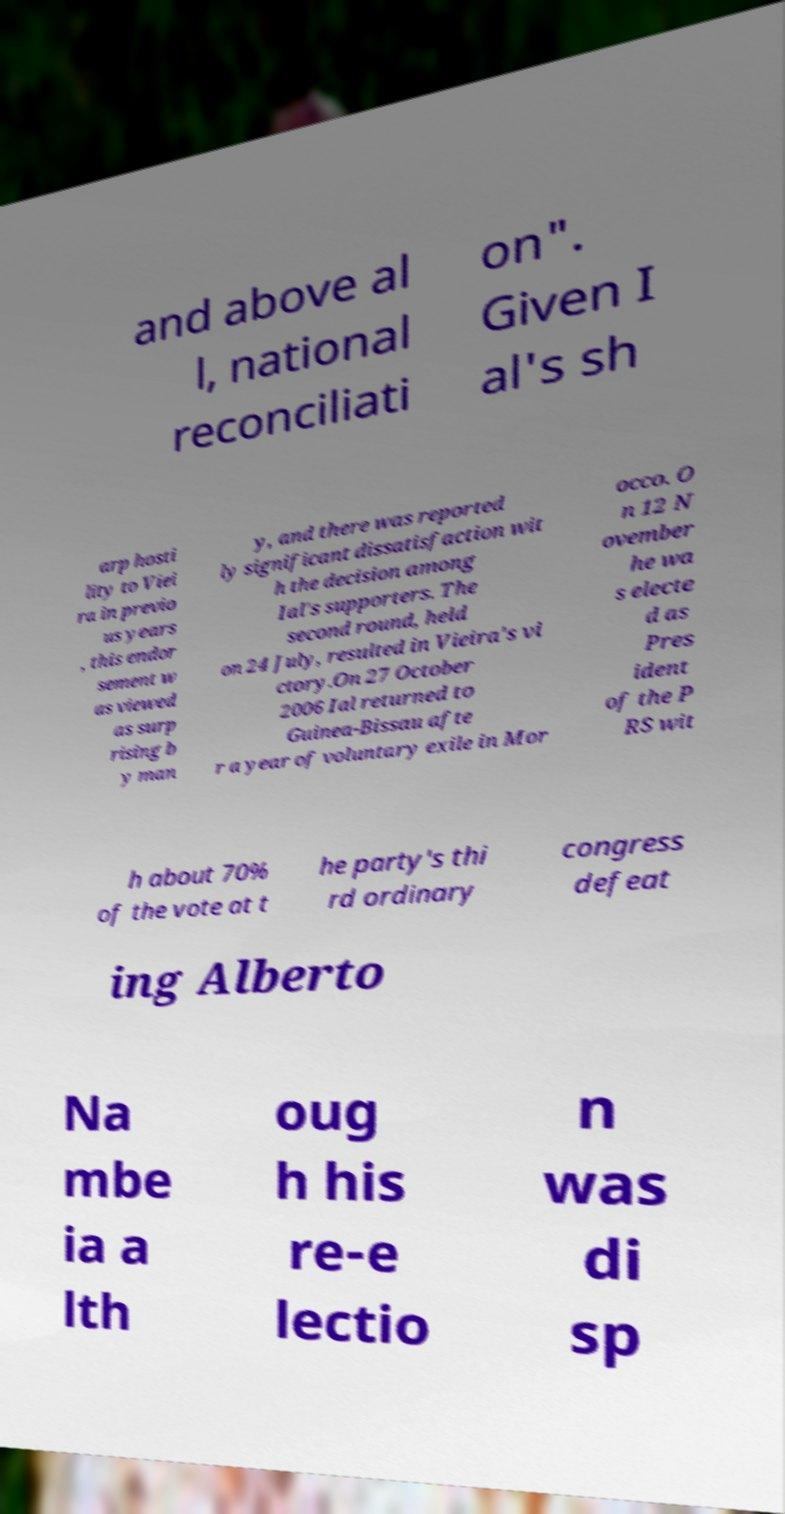For documentation purposes, I need the text within this image transcribed. Could you provide that? and above al l, national reconciliati on". Given I al's sh arp hosti lity to Viei ra in previo us years , this endor sement w as viewed as surp rising b y man y, and there was reported ly significant dissatisfaction wit h the decision among Ial's supporters. The second round, held on 24 July, resulted in Vieira's vi ctory.On 27 October 2006 Ial returned to Guinea-Bissau afte r a year of voluntary exile in Mor occo. O n 12 N ovember he wa s electe d as Pres ident of the P RS wit h about 70% of the vote at t he party's thi rd ordinary congress defeat ing Alberto Na mbe ia a lth oug h his re-e lectio n was di sp 